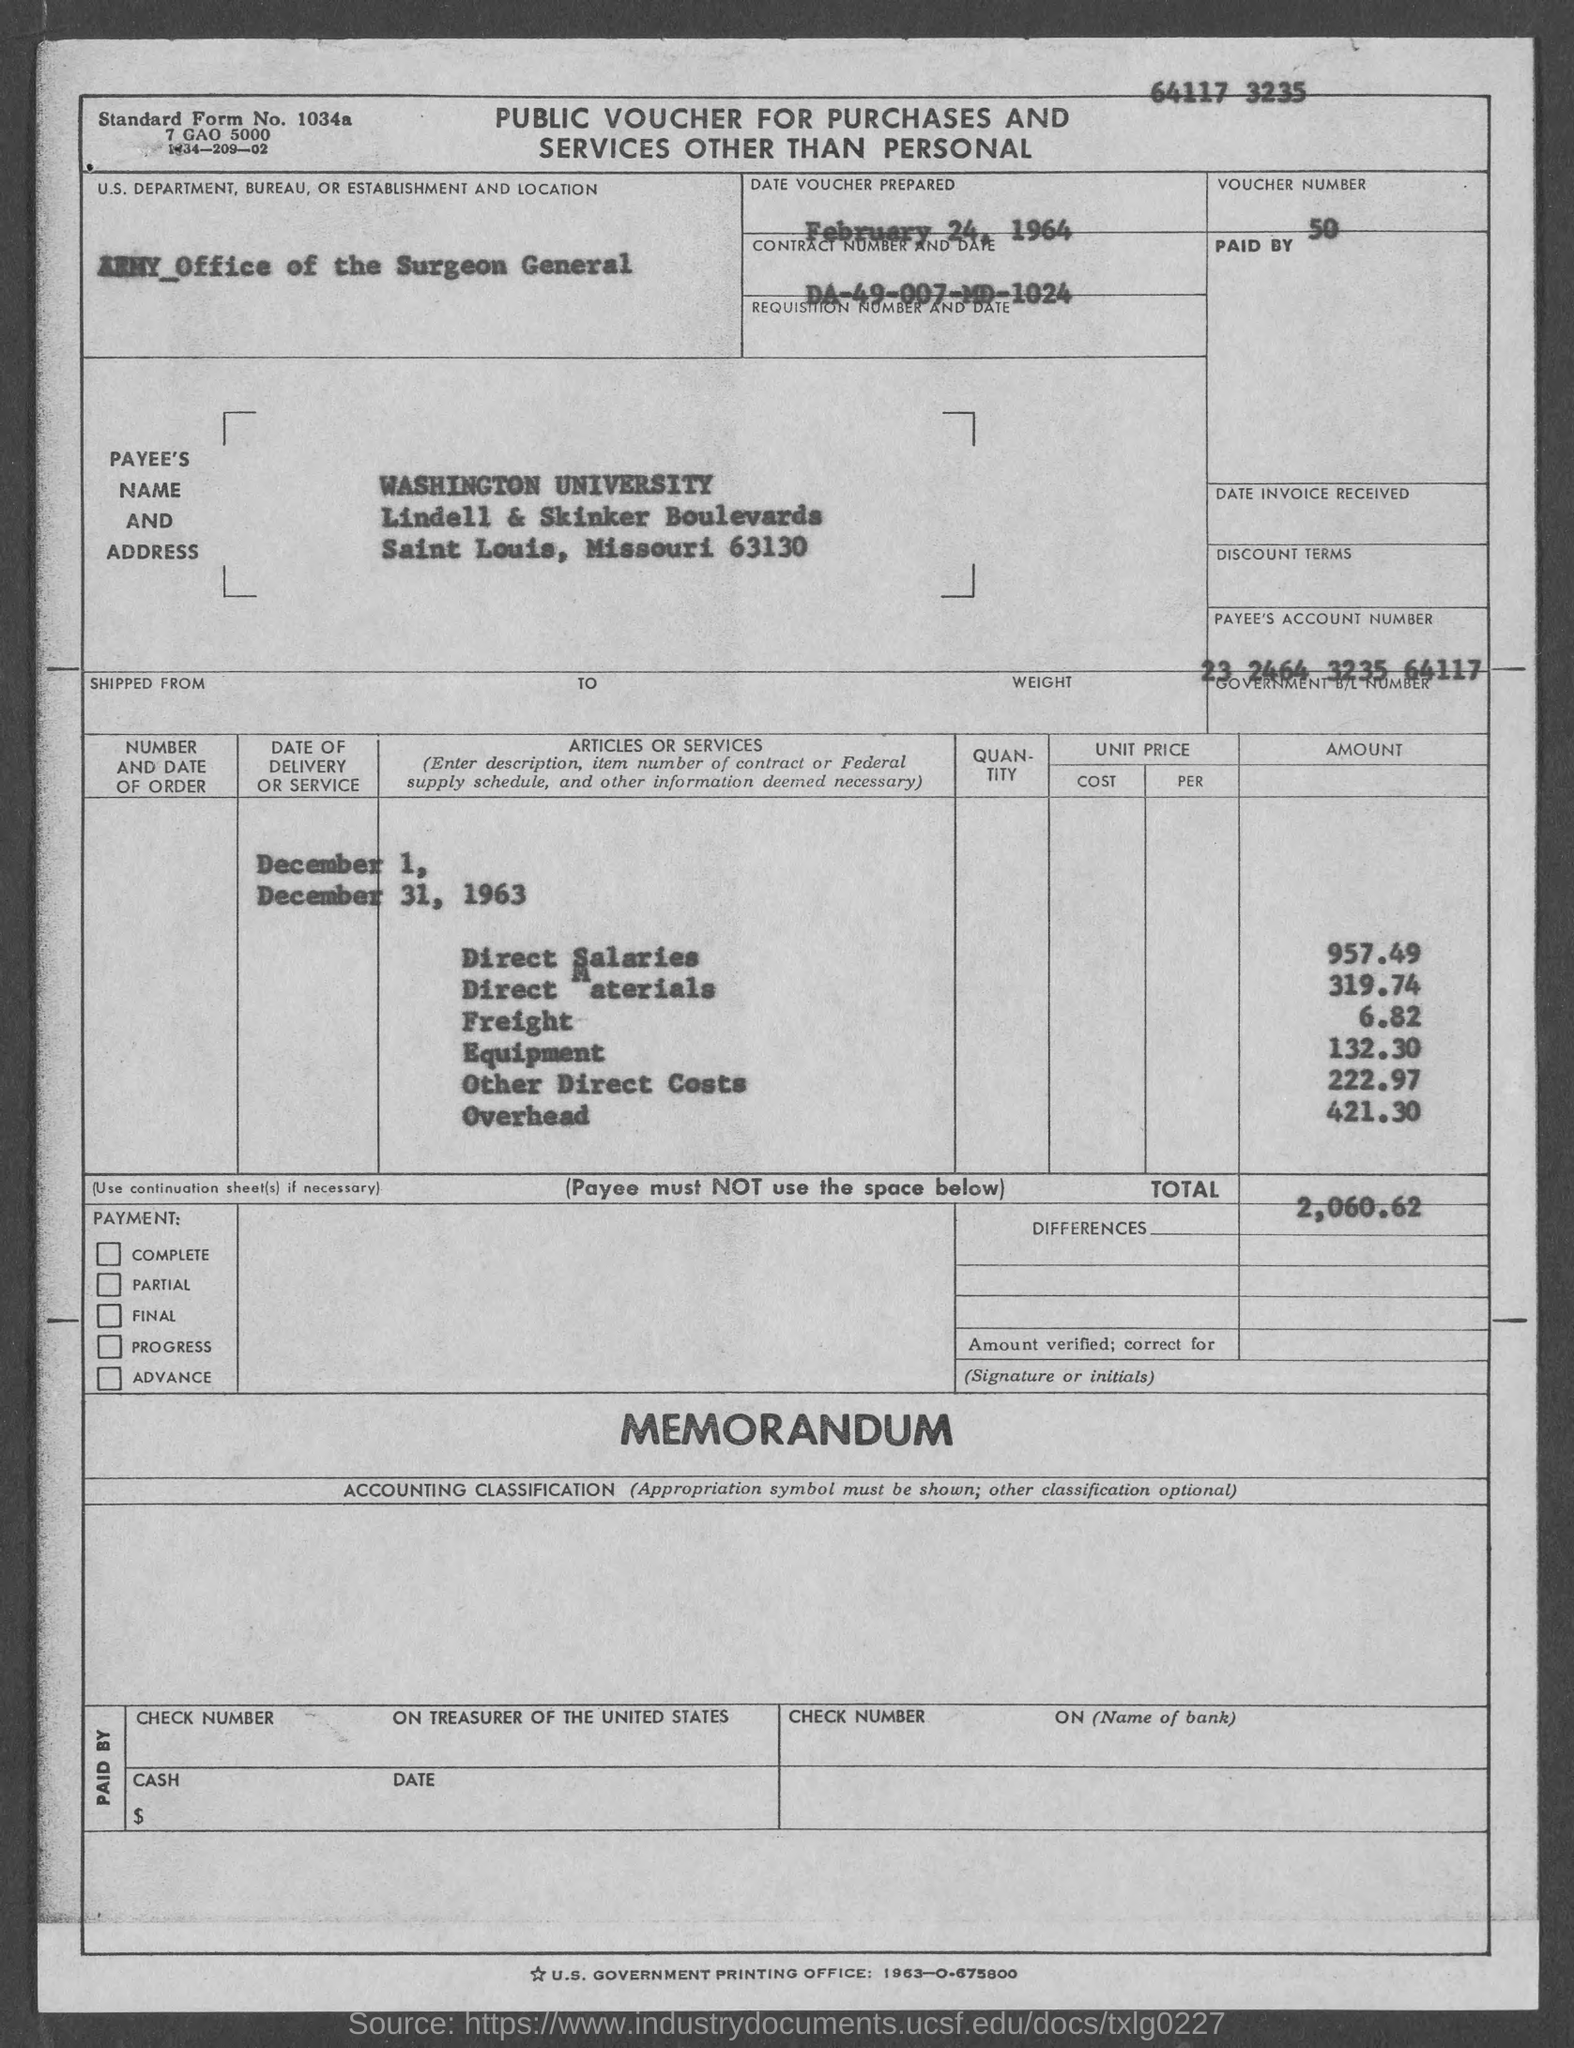Point out several critical features in this image. The voucher number provided in the document is 50. The payee name mentioned in the voucher is "Washington University. The Contract No. specified in the voucher is da-49-007-md-1024. The direct salaries cost listed in the voucher is 957.49. The payee's account number provided in the voucher is 23 2464 3235 64117. 